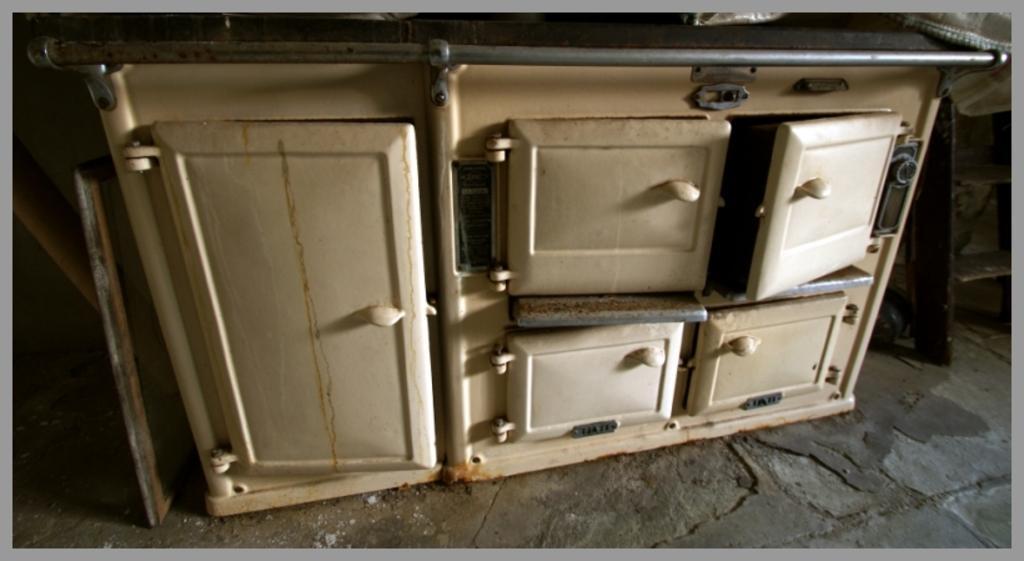Can you describe this image briefly? In this image we can see a cupboard and some other objects on the floor. 